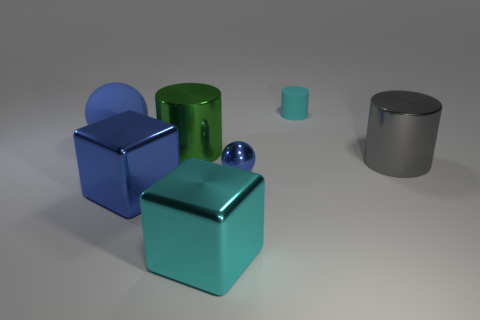Is the cyan metallic object the same shape as the small cyan rubber object?
Offer a very short reply. No. What is the material of the cyan object that is the same shape as the large green thing?
Your response must be concise. Rubber. Are there any metallic things behind the cyan object that is in front of the object that is to the left of the big blue cube?
Offer a terse response. Yes. Does the tiny blue thing have the same shape as the large blue rubber object behind the big cyan shiny cube?
Provide a succinct answer. Yes. Is there anything else of the same color as the rubber ball?
Ensure brevity in your answer.  Yes. Does the shiny cube behind the large cyan thing have the same color as the object right of the small rubber cylinder?
Make the answer very short. No. Is there a big red ball?
Provide a short and direct response. No. Are there any small cyan cylinders made of the same material as the large gray cylinder?
Provide a short and direct response. No. The large rubber ball has what color?
Keep it short and to the point. Blue. What shape is the tiny shiny object that is the same color as the big matte object?
Offer a very short reply. Sphere. 